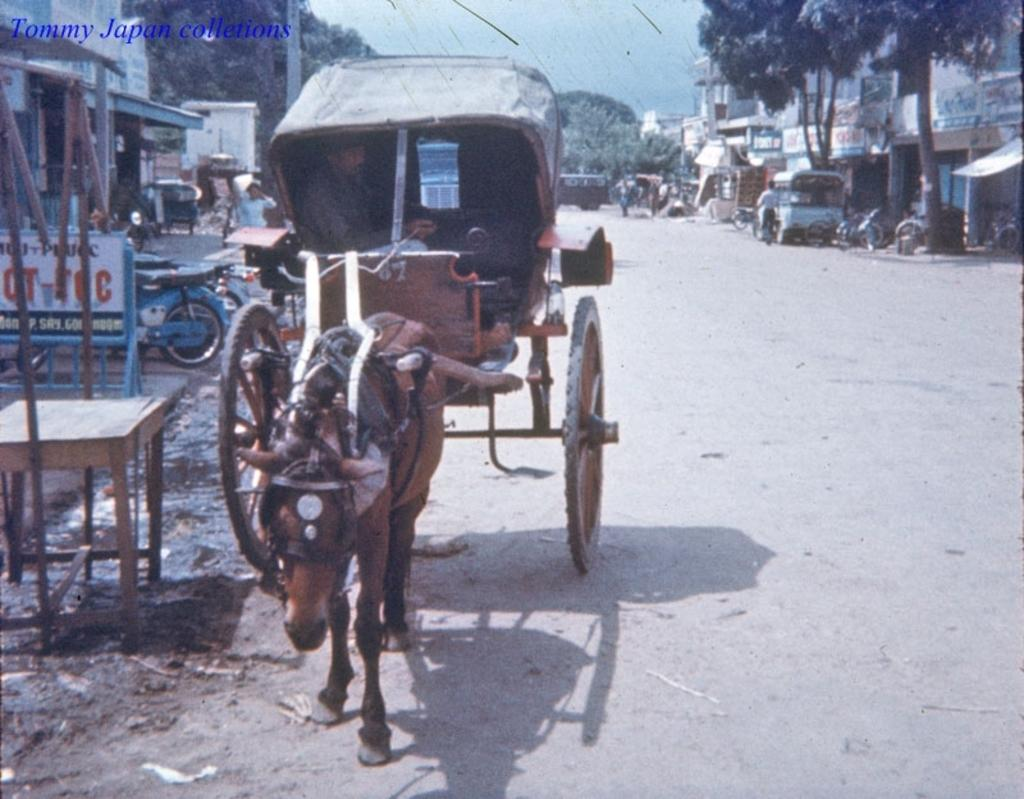What mode of transportation is the person using in the image? The person is in a horse cart in the image. What object is visible near the person? There is a board visible in the image. What type of vehicle can be seen in the image? There is a vehicle in the image. What can be seen in the distance behind the person? There are buildings, trees, and people in the background, as well as a pole and the sky. How many chickens are sitting on the person's lap in the image? There are no chickens present in the image. What nerve is being stimulated by the person's presence in the horse cart? The image does not provide information about any nerves being stimulated. 